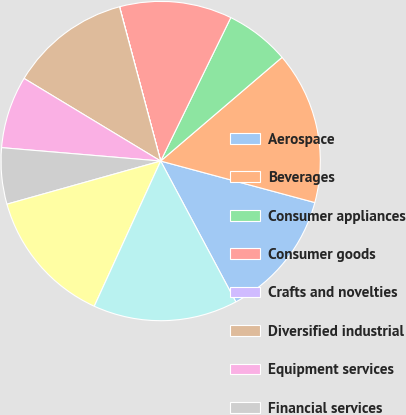<chart> <loc_0><loc_0><loc_500><loc_500><pie_chart><fcel>Aerospace<fcel>Beverages<fcel>Consumer appliances<fcel>Consumer goods<fcel>Crafts and novelties<fcel>Diversified industrial<fcel>Equipment services<fcel>Financial services<fcel>Food processing<fcel>Government services<nl><fcel>13.01%<fcel>15.44%<fcel>6.51%<fcel>11.38%<fcel>0.01%<fcel>12.19%<fcel>7.32%<fcel>5.69%<fcel>13.82%<fcel>14.63%<nl></chart> 